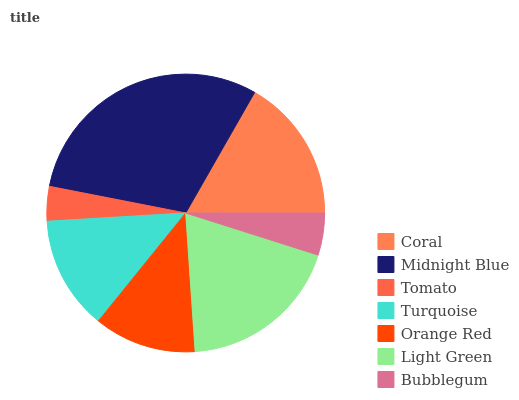Is Tomato the minimum?
Answer yes or no. Yes. Is Midnight Blue the maximum?
Answer yes or no. Yes. Is Midnight Blue the minimum?
Answer yes or no. No. Is Tomato the maximum?
Answer yes or no. No. Is Midnight Blue greater than Tomato?
Answer yes or no. Yes. Is Tomato less than Midnight Blue?
Answer yes or no. Yes. Is Tomato greater than Midnight Blue?
Answer yes or no. No. Is Midnight Blue less than Tomato?
Answer yes or no. No. Is Turquoise the high median?
Answer yes or no. Yes. Is Turquoise the low median?
Answer yes or no. Yes. Is Tomato the high median?
Answer yes or no. No. Is Bubblegum the low median?
Answer yes or no. No. 